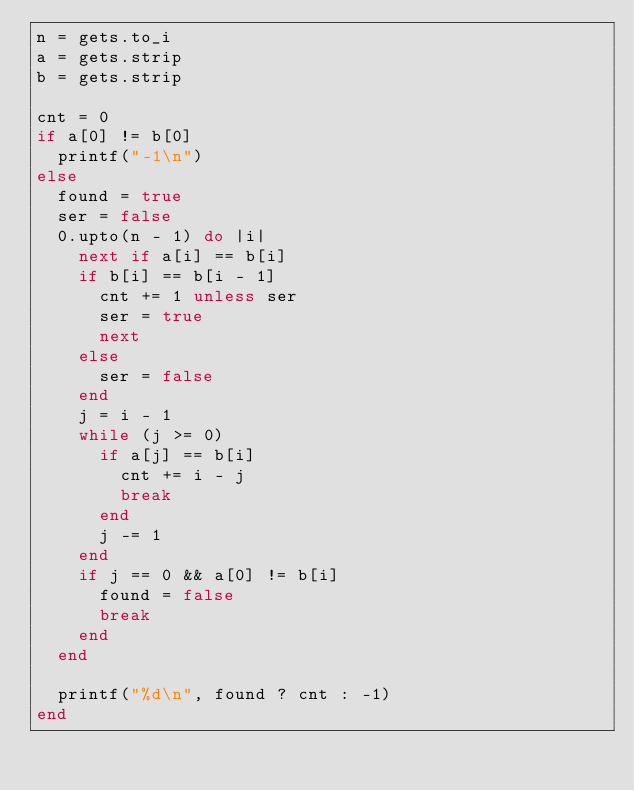<code> <loc_0><loc_0><loc_500><loc_500><_Ruby_>n = gets.to_i
a = gets.strip
b = gets.strip

cnt = 0
if a[0] != b[0]
  printf("-1\n")
else
  found = true
  ser = false
  0.upto(n - 1) do |i|
    next if a[i] == b[i]
    if b[i] == b[i - 1]
      cnt += 1 unless ser
      ser = true
      next
    else
      ser = false
    end
    j = i - 1
    while (j >= 0)
      if a[j] == b[i]
        cnt += i - j
        break
      end
      j -= 1
    end
    if j == 0 && a[0] != b[i]
      found = false
      break
    end
  end

  printf("%d\n", found ? cnt : -1)
end
</code> 